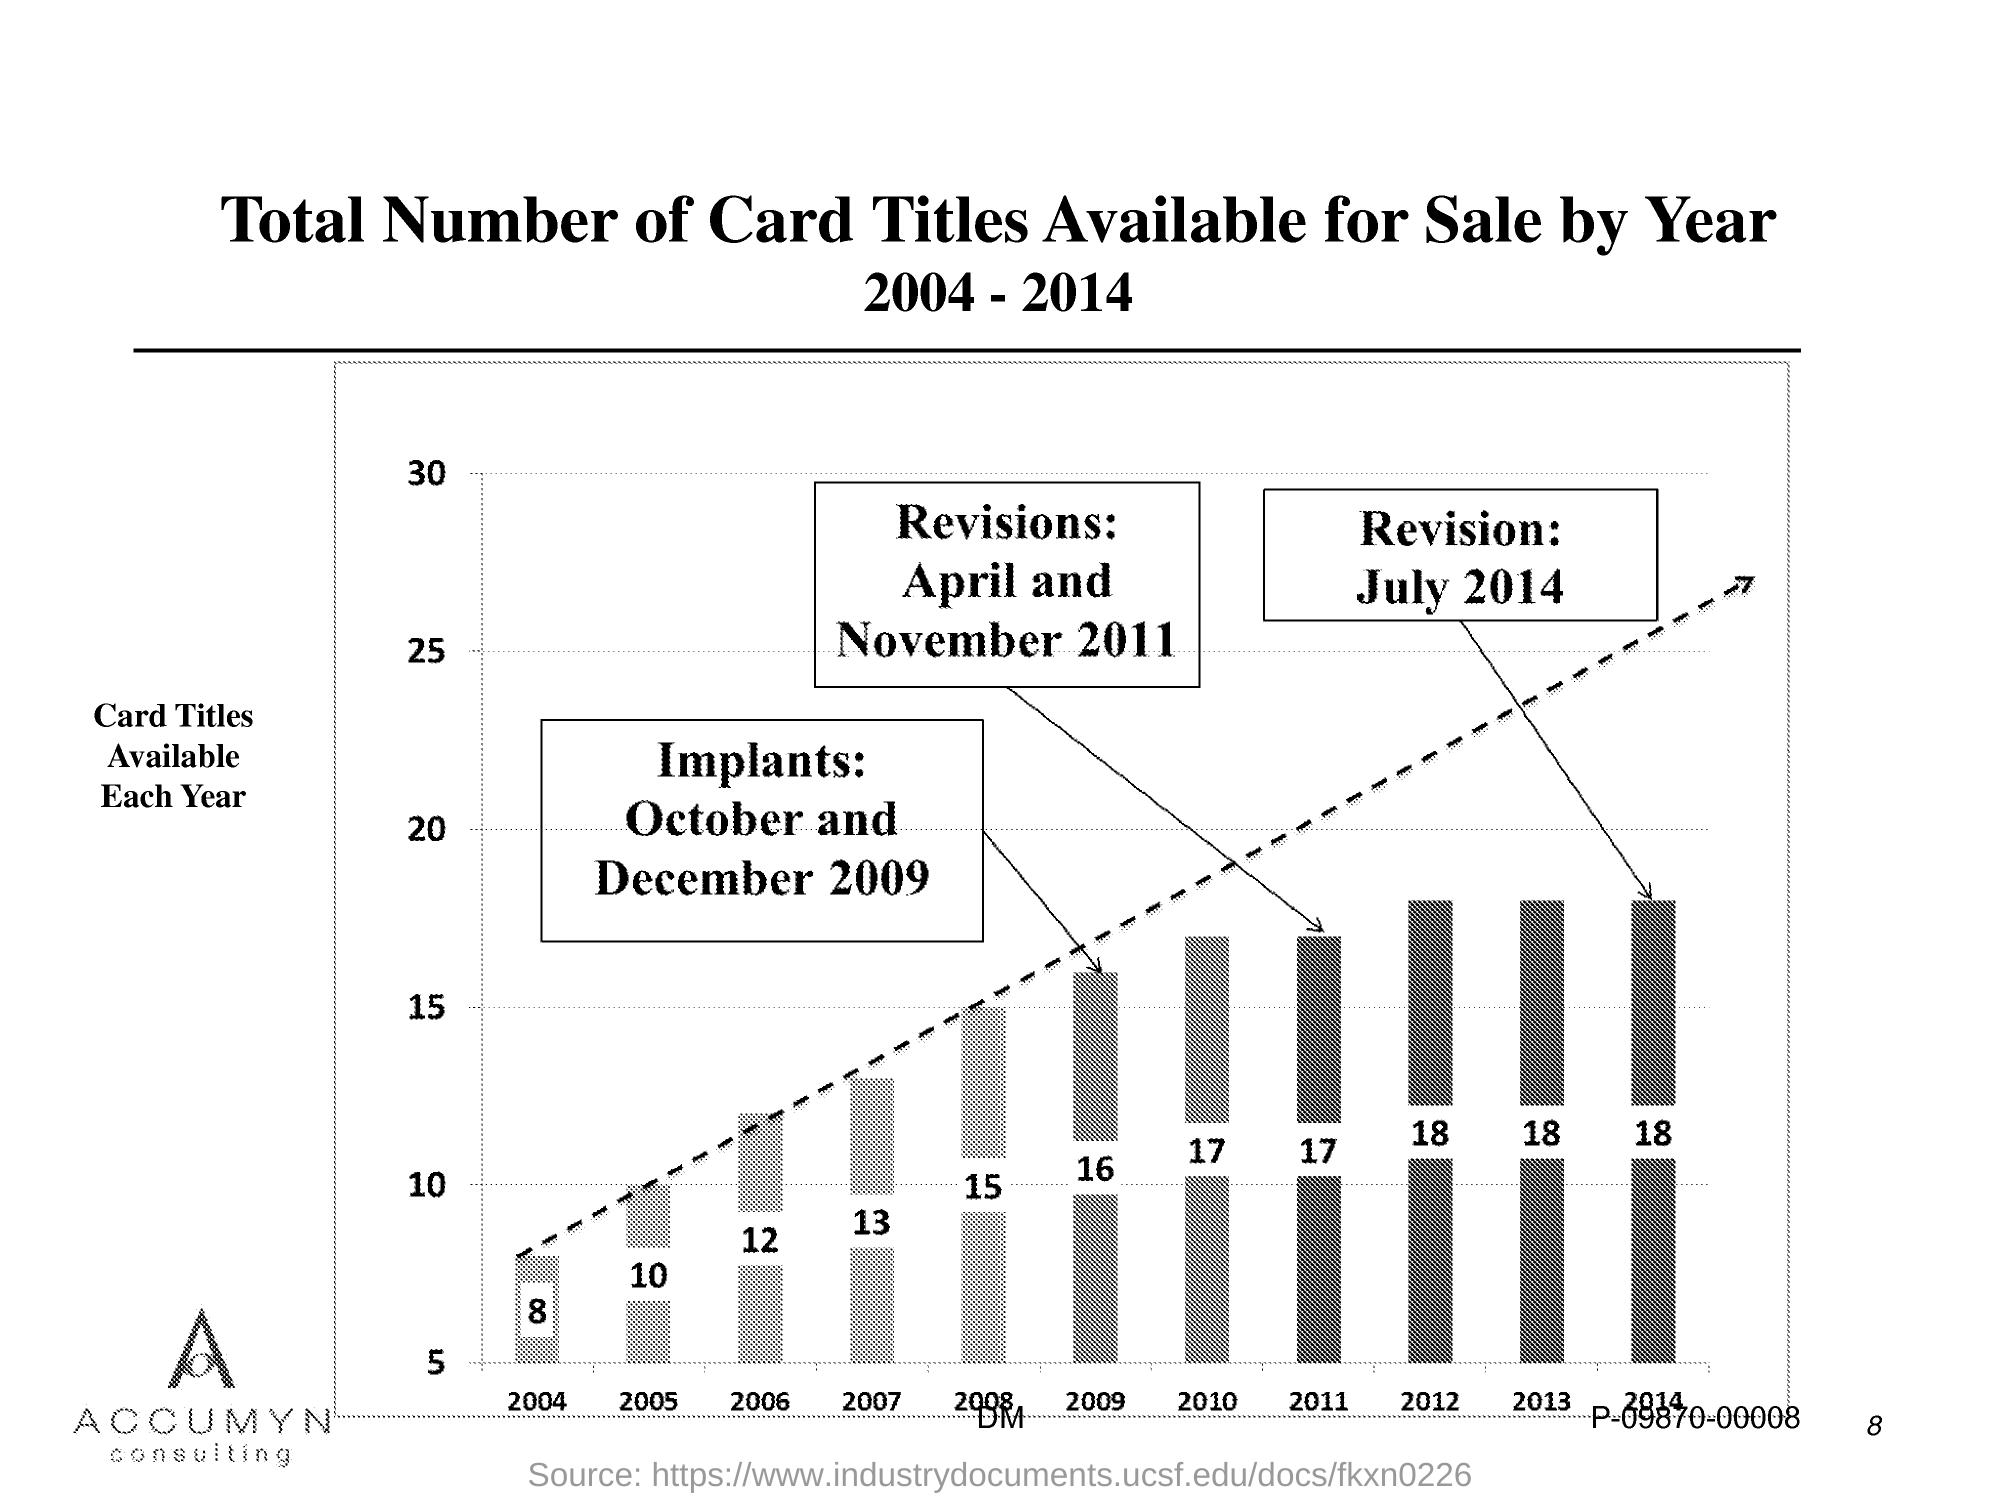What is plotted in the y-axis?
Your answer should be compact. CARD TITLES AVAILABLE EACH YEAR. What is the Page Number?
Give a very brief answer. 8. 